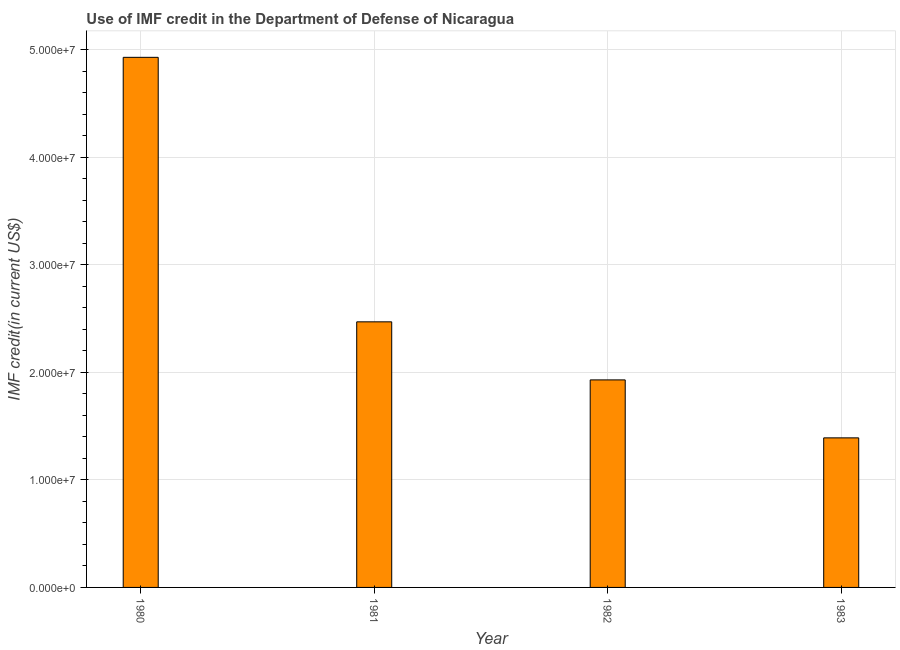Does the graph contain any zero values?
Offer a very short reply. No. What is the title of the graph?
Offer a very short reply. Use of IMF credit in the Department of Defense of Nicaragua. What is the label or title of the X-axis?
Make the answer very short. Year. What is the label or title of the Y-axis?
Provide a succinct answer. IMF credit(in current US$). What is the use of imf credit in dod in 1980?
Keep it short and to the point. 4.93e+07. Across all years, what is the maximum use of imf credit in dod?
Keep it short and to the point. 4.93e+07. Across all years, what is the minimum use of imf credit in dod?
Your answer should be compact. 1.39e+07. In which year was the use of imf credit in dod maximum?
Your answer should be compact. 1980. What is the sum of the use of imf credit in dod?
Give a very brief answer. 1.07e+08. What is the difference between the use of imf credit in dod in 1981 and 1983?
Offer a very short reply. 1.08e+07. What is the average use of imf credit in dod per year?
Give a very brief answer. 2.68e+07. What is the median use of imf credit in dod?
Your answer should be compact. 2.20e+07. In how many years, is the use of imf credit in dod greater than 2000000 US$?
Provide a succinct answer. 4. Do a majority of the years between 1983 and 1981 (inclusive) have use of imf credit in dod greater than 6000000 US$?
Your response must be concise. Yes. What is the ratio of the use of imf credit in dod in 1982 to that in 1983?
Ensure brevity in your answer.  1.39. What is the difference between the highest and the second highest use of imf credit in dod?
Keep it short and to the point. 2.46e+07. Is the sum of the use of imf credit in dod in 1980 and 1983 greater than the maximum use of imf credit in dod across all years?
Your response must be concise. Yes. What is the difference between the highest and the lowest use of imf credit in dod?
Your answer should be compact. 3.54e+07. How many bars are there?
Keep it short and to the point. 4. Are all the bars in the graph horizontal?
Offer a terse response. No. What is the difference between two consecutive major ticks on the Y-axis?
Your answer should be very brief. 1.00e+07. What is the IMF credit(in current US$) of 1980?
Offer a terse response. 4.93e+07. What is the IMF credit(in current US$) in 1981?
Your response must be concise. 2.47e+07. What is the IMF credit(in current US$) in 1982?
Provide a short and direct response. 1.93e+07. What is the IMF credit(in current US$) of 1983?
Offer a very short reply. 1.39e+07. What is the difference between the IMF credit(in current US$) in 1980 and 1981?
Your answer should be compact. 2.46e+07. What is the difference between the IMF credit(in current US$) in 1980 and 1982?
Your answer should be very brief. 3.00e+07. What is the difference between the IMF credit(in current US$) in 1980 and 1983?
Offer a terse response. 3.54e+07. What is the difference between the IMF credit(in current US$) in 1981 and 1982?
Make the answer very short. 5.40e+06. What is the difference between the IMF credit(in current US$) in 1981 and 1983?
Make the answer very short. 1.08e+07. What is the difference between the IMF credit(in current US$) in 1982 and 1983?
Give a very brief answer. 5.39e+06. What is the ratio of the IMF credit(in current US$) in 1980 to that in 1981?
Your response must be concise. 2. What is the ratio of the IMF credit(in current US$) in 1980 to that in 1982?
Provide a succinct answer. 2.55. What is the ratio of the IMF credit(in current US$) in 1980 to that in 1983?
Your answer should be compact. 3.54. What is the ratio of the IMF credit(in current US$) in 1981 to that in 1982?
Provide a short and direct response. 1.28. What is the ratio of the IMF credit(in current US$) in 1981 to that in 1983?
Provide a short and direct response. 1.78. What is the ratio of the IMF credit(in current US$) in 1982 to that in 1983?
Ensure brevity in your answer.  1.39. 